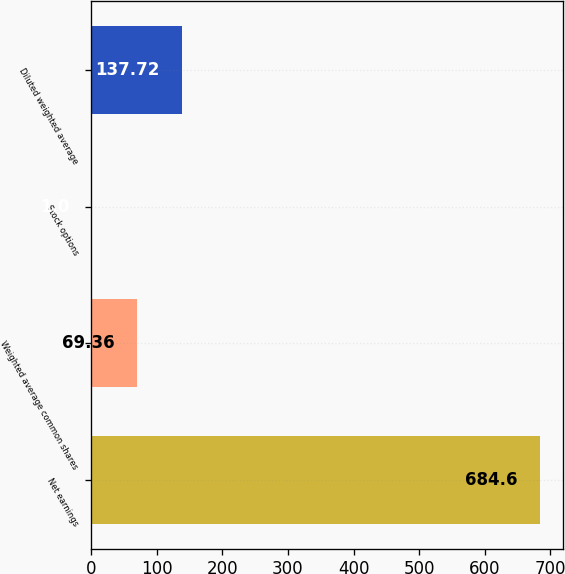<chart> <loc_0><loc_0><loc_500><loc_500><bar_chart><fcel>Net earnings<fcel>Weighted average common shares<fcel>Stock options<fcel>Diluted weighted average<nl><fcel>684.6<fcel>69.36<fcel>1<fcel>137.72<nl></chart> 